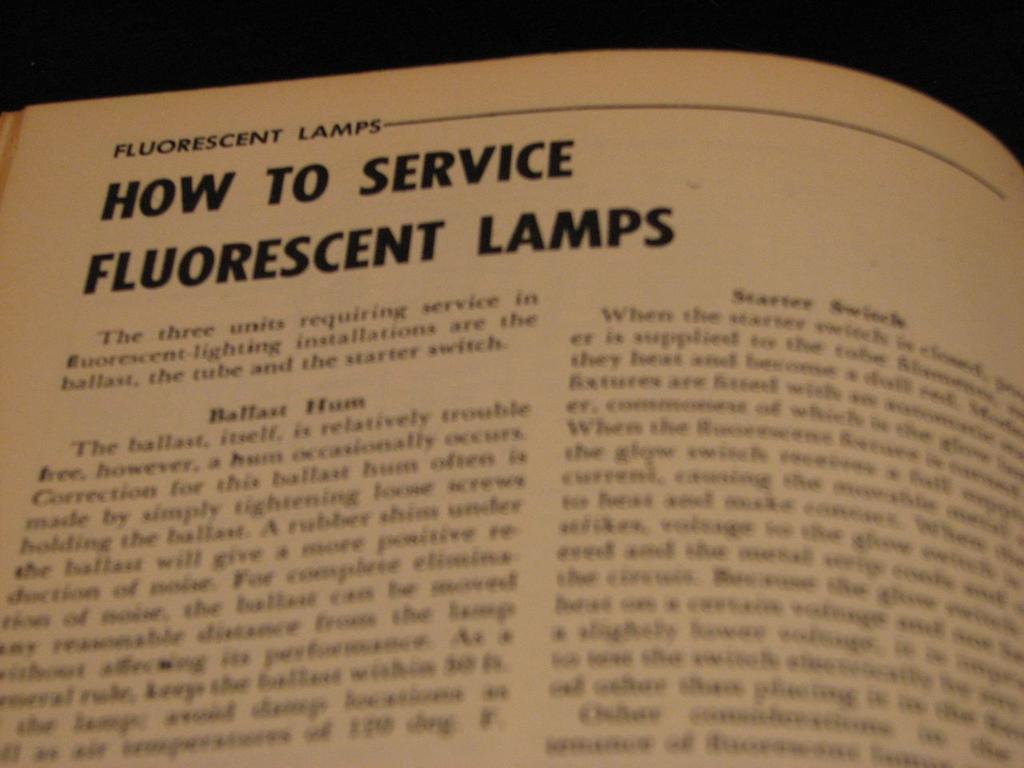What is the title of the chapter?
Give a very brief answer. How to service fluorescent lamps. The title is how to service fluorescent lamps?
Your response must be concise. Yes. 